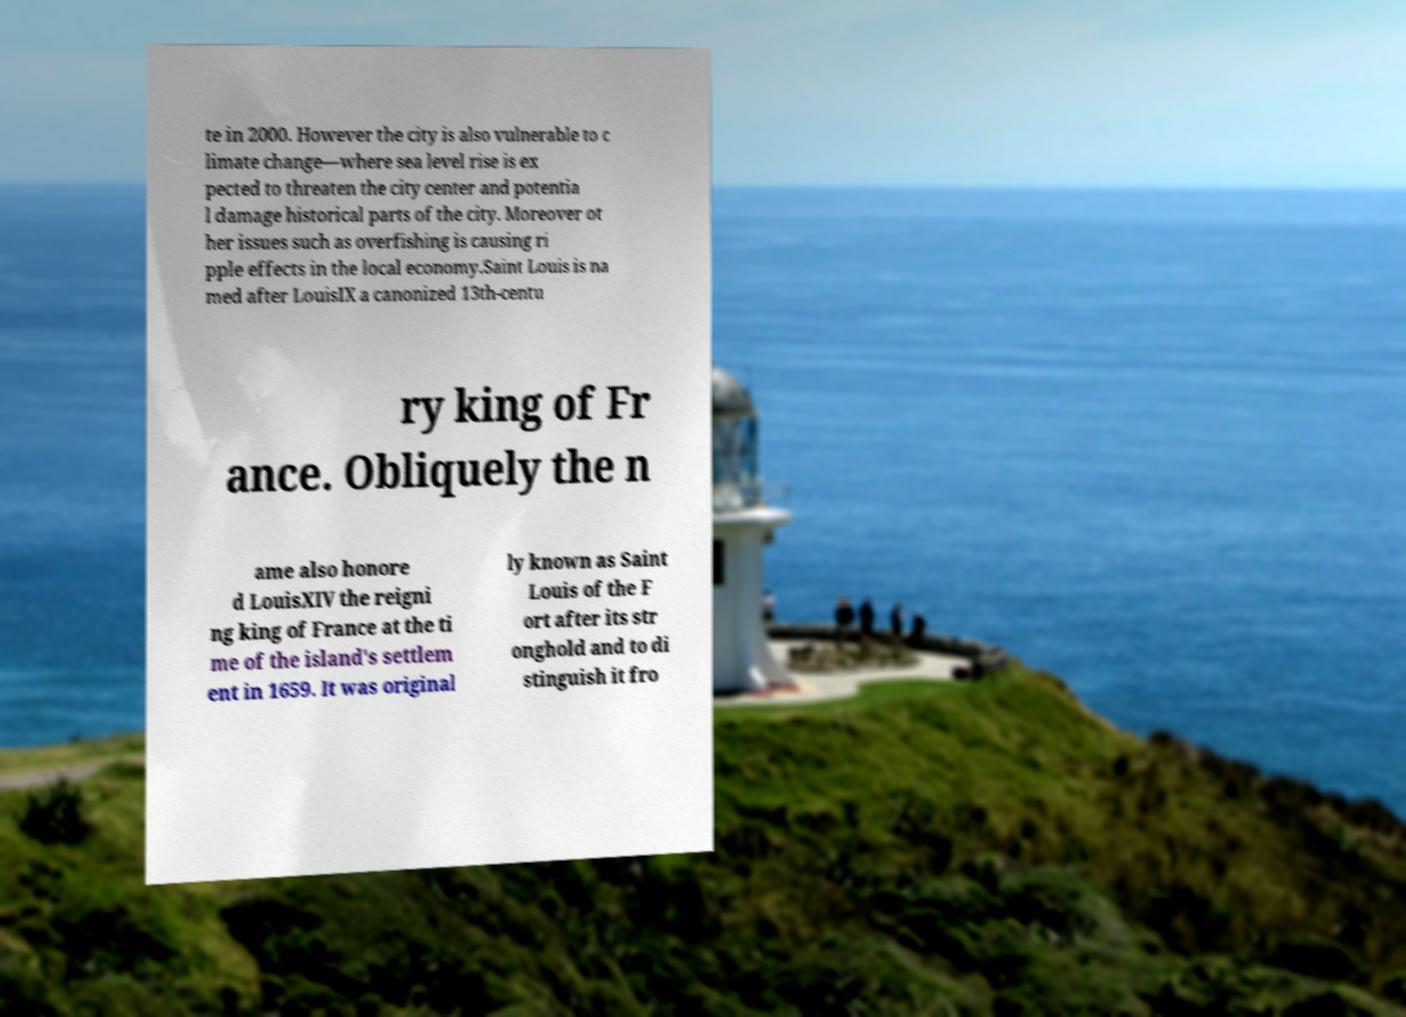Can you read and provide the text displayed in the image?This photo seems to have some interesting text. Can you extract and type it out for me? te in 2000. However the city is also vulnerable to c limate change—where sea level rise is ex pected to threaten the city center and potentia l damage historical parts of the city. Moreover ot her issues such as overfishing is causing ri pple effects in the local economy.Saint Louis is na med after LouisIX a canonized 13th-centu ry king of Fr ance. Obliquely the n ame also honore d LouisXIV the reigni ng king of France at the ti me of the island's settlem ent in 1659. It was original ly known as Saint Louis of the F ort after its str onghold and to di stinguish it fro 